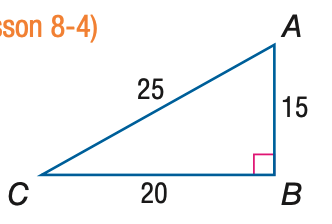Question: Express the ratio of \sin A as a decimal to the nearest hundredth.
Choices:
A. 0.60
B. 0.75
C. 0.80
D. 1.33
Answer with the letter. Answer: C Question: Express the ratio of \cos C as a decimal to the nearest hundredth.
Choices:
A. 0.60
B. 0.75
C. 0.80
D. 1.33
Answer with the letter. Answer: C Question: Express the ratio of \tan A as a decimal to the nearest hundredth.
Choices:
A. 0.60
B. 0.80
C. 1.33
D. 1.67
Answer with the letter. Answer: C Question: Express the ratio of \tan C as a decimal to the nearest hundredth.
Choices:
A. 0.60
B. 0.75
C. 0.80
D. 1.33
Answer with the letter. Answer: B Question: Express the ratio of \sin C as a decimal to the nearest hundredth.
Choices:
A. 0.60
B. 0.75
C. 0.80
D. 1.33
Answer with the letter. Answer: A 